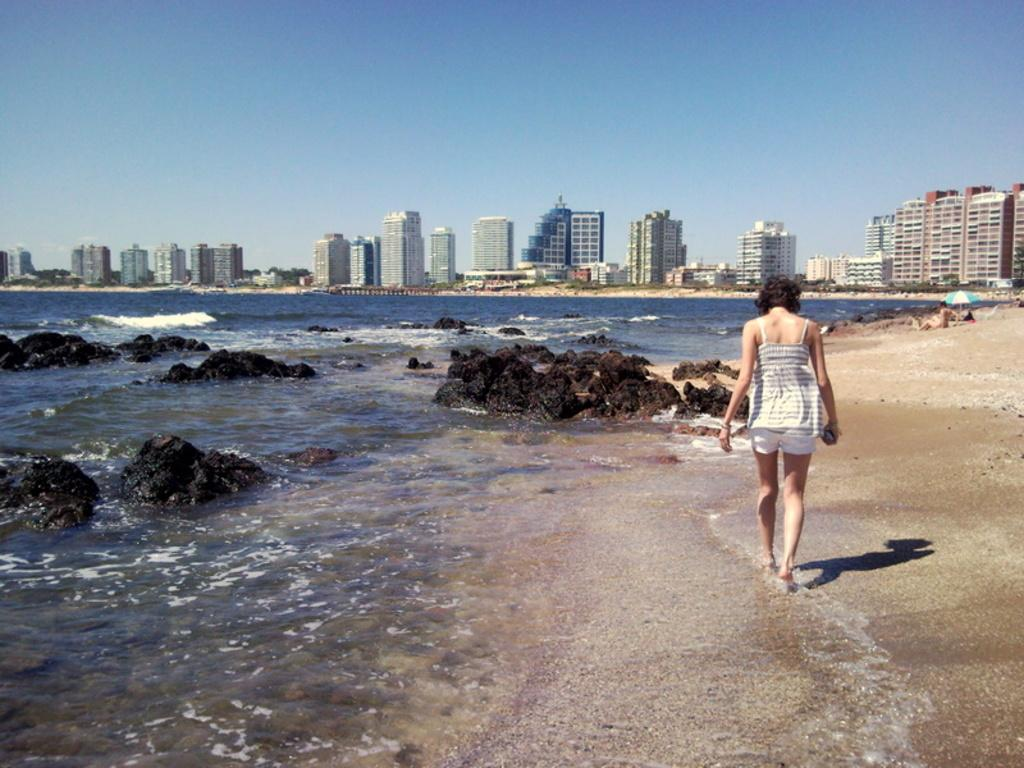What type of structures can be seen in the image? There are buildings in the image. What natural elements are present in the image? There are trees and water in the image. What is visible in the sky in the image? The sky is visible in the image. What is located at the bottom of the image? There is water at the bottom of the image. What objects can be found in the water? Rocks are present in the water. Where is the person located in the image? The person is on the right side of the image. What type of writer can be seen holding a camera in the image? There is no writer or camera present in the image. How many bags of popcorn are visible in the image? There are no bags of popcorn present in the image. 